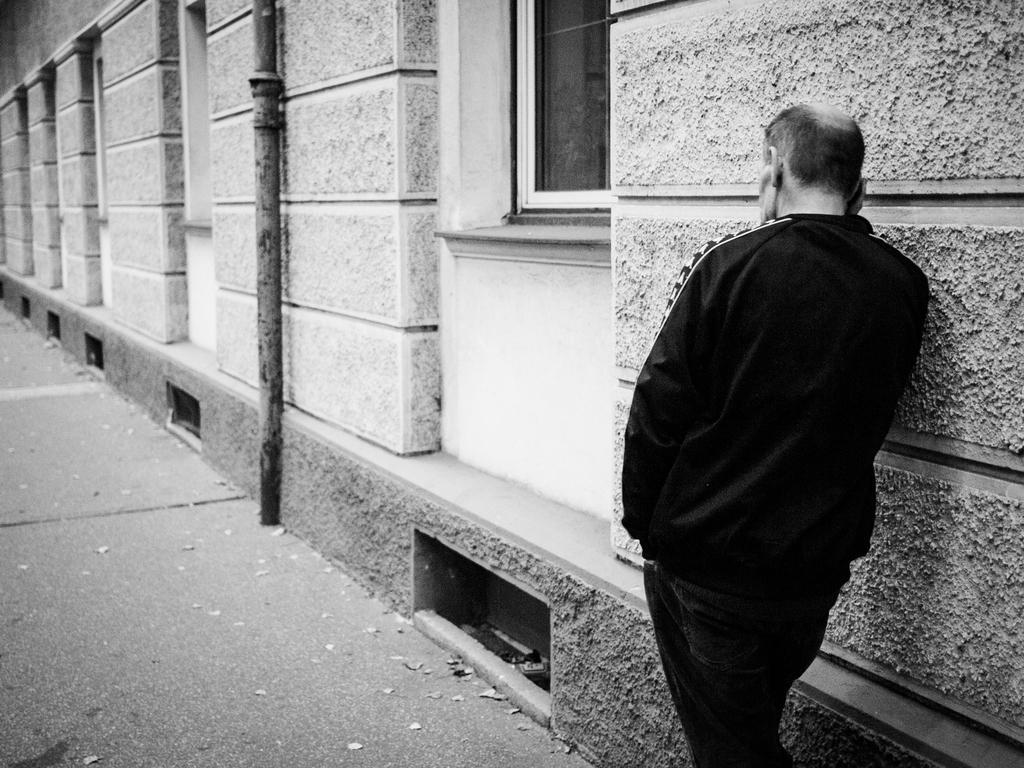Can you describe this image briefly? This is a black and white image. On the right side of the image, we can see a person is standing near the wall and holding an object. In the middle of the image, we can see the pipe and glass window. At the bottom of the image, there is a walkway. 